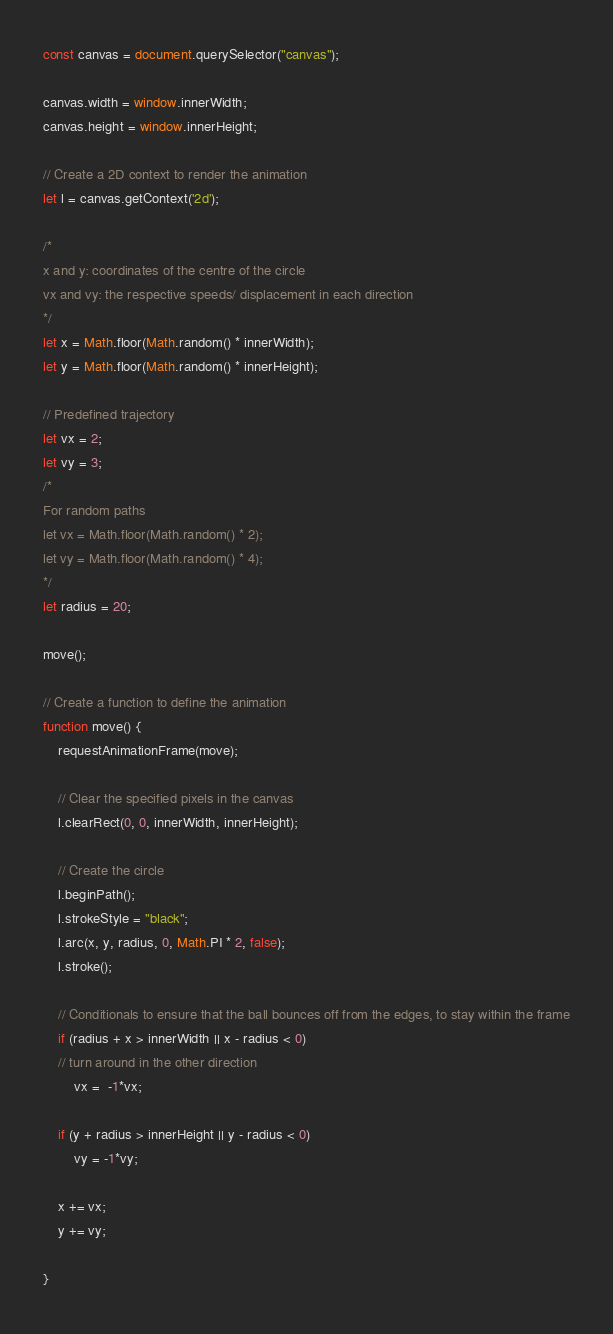Convert code to text. <code><loc_0><loc_0><loc_500><loc_500><_JavaScript_>
const canvas = document.querySelector("canvas");

canvas.width = window.innerWidth;
canvas.height = window.innerHeight;

// Create a 2D context to render the animation
let l = canvas.getContext('2d');

/*
x and y: coordinates of the centre of the circle
vx and vy: the respective speeds/ displacement in each direction
*/
let x = Math.floor(Math.random() * innerWidth);
let y = Math.floor(Math.random() * innerHeight);

// Predefined trajectory
let vx = 2;
let vy = 3;
/*
For random paths
let vx = Math.floor(Math.random() * 2);
let vy = Math.floor(Math.random() * 4);
*/
let radius = 20;

move();

// Create a function to define the animation
function move() {
    requestAnimationFrame(move);

    // Clear the specified pixels in the canvas
    l.clearRect(0, 0, innerWidth, innerHeight);

    // Create the circle
    l.beginPath();
    l.strokeStyle = "black";
    l.arc(x, y, radius, 0, Math.PI * 2, false);
    l.stroke();

    // Conditionals to ensure that the ball bounces off from the edges, to stay within the frame
    if (radius + x > innerWidth || x - radius < 0)
    // turn around in the other direction
        vx =  -1*vx;

    if (y + radius > innerHeight || y - radius < 0)
        vy = -1*vy;

    x += vx;
    y += vy;

}
</code> 